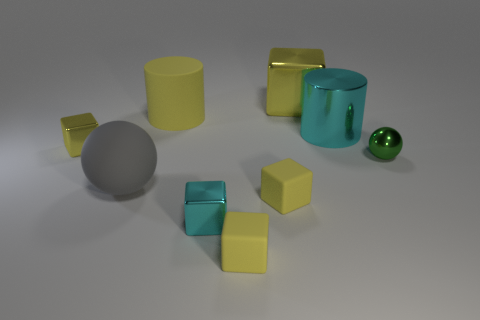What number of metal objects are either yellow cylinders or large cyan cylinders?
Ensure brevity in your answer.  1. What is the size of the other thing that is the same shape as the gray matte thing?
Your response must be concise. Small. Are there any other things that are the same size as the yellow rubber cylinder?
Offer a very short reply. Yes. There is a matte cylinder; does it have the same size as the sphere to the right of the cyan metal cube?
Keep it short and to the point. No. The big yellow object that is in front of the big yellow metal object has what shape?
Your answer should be very brief. Cylinder. What color is the shiny cube that is behind the tiny yellow object that is behind the small green shiny object?
Keep it short and to the point. Yellow. What color is the other thing that is the same shape as the gray thing?
Your response must be concise. Green. How many cubes have the same color as the large metallic cylinder?
Offer a very short reply. 1. There is a large metal cylinder; does it have the same color as the large cylinder that is left of the small cyan object?
Your answer should be very brief. No. There is a small shiny object that is both on the left side of the tiny ball and right of the large yellow rubber cylinder; what is its shape?
Offer a terse response. Cube. 